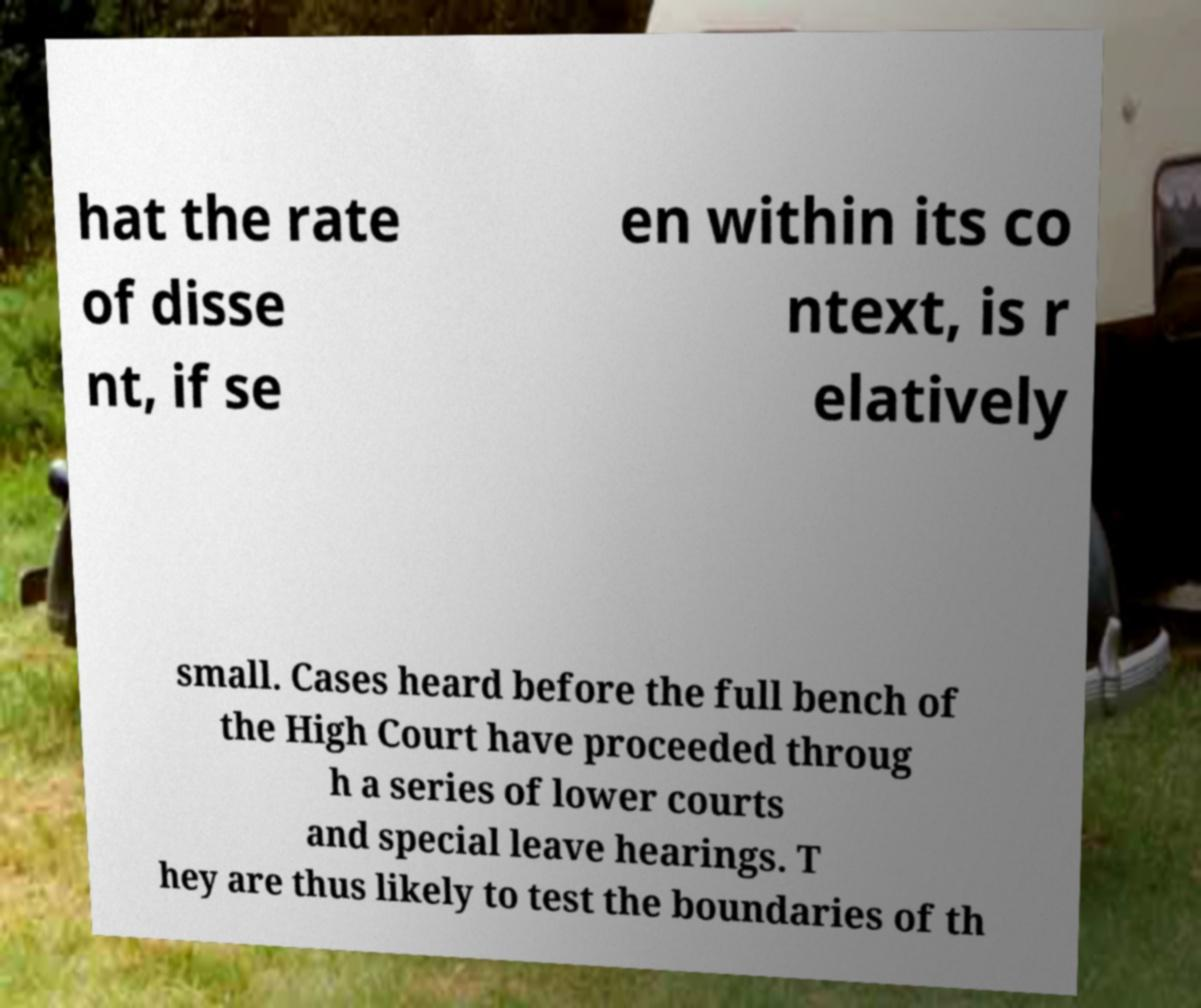Please read and relay the text visible in this image. What does it say? hat the rate of disse nt, if se en within its co ntext, is r elatively small. Cases heard before the full bench of the High Court have proceeded throug h a series of lower courts and special leave hearings. T hey are thus likely to test the boundaries of th 